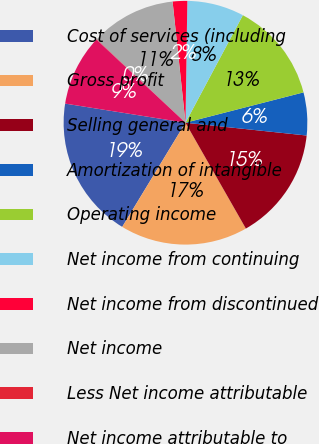Convert chart. <chart><loc_0><loc_0><loc_500><loc_500><pie_chart><fcel>Cost of services (including<fcel>Gross profit<fcel>Selling general and<fcel>Amortization of intangible<fcel>Operating income<fcel>Net income from continuing<fcel>Net income from discontinued<fcel>Net income<fcel>Less Net income attributable<fcel>Net income attributable to<nl><fcel>18.82%<fcel>16.94%<fcel>15.07%<fcel>5.68%<fcel>13.19%<fcel>7.56%<fcel>1.93%<fcel>11.31%<fcel>0.05%<fcel>9.44%<nl></chart> 